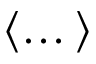Convert formula to latex. <formula><loc_0><loc_0><loc_500><loc_500>\langle \dots \rangle</formula> 